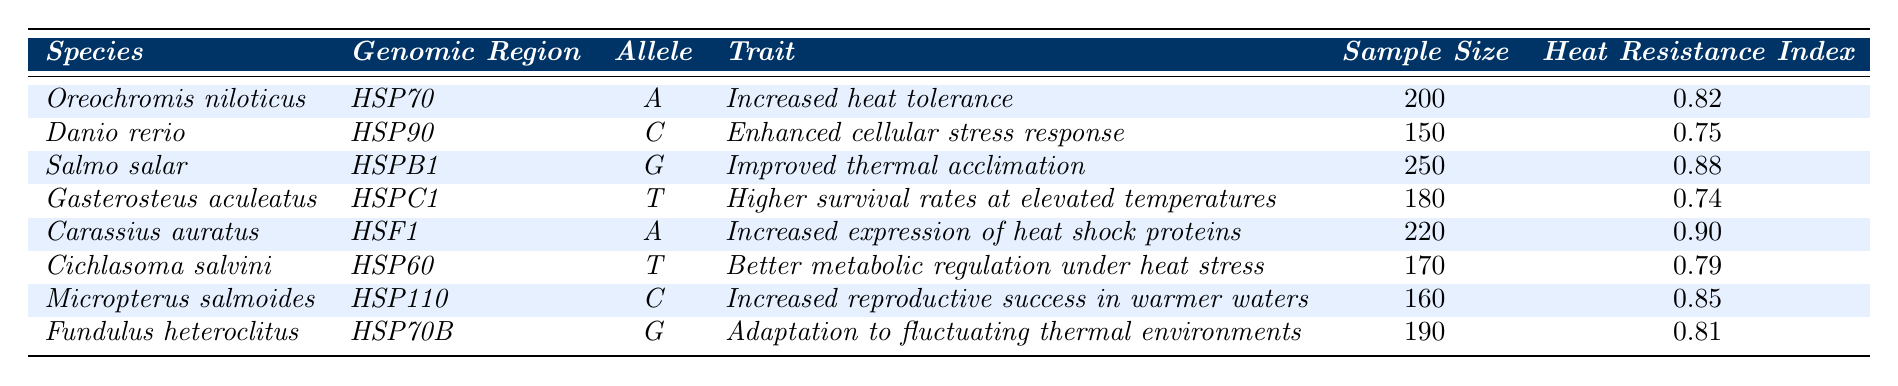What is the heat resistance index for *Salmo salar*? The heat resistance index for *Salmo salar* is directly listed in the table under the corresponding row. It states 0.88 for this species.
Answer: 0.88 Which species has the highest heat resistance index? By comparing the heat resistance index values in the table, *Carassius auratus* has the highest value at 0.90.
Answer: *Carassius auratus* What is the sample size of fish populations for *Gasterosteus aculeatus*? The sample size for *Gasterosteus aculeatus* is explicitly mentioned in the table, which shows a value of 180.
Answer: 180 Is the allele for *Danio rerio* associated with increased heat tolerance? By checking the table, *Danio rerio* has the trait "Enhanced cellular stress response," which is not the same as increased heat tolerance; thus, the answer is no.
Answer: No What is the sum of the heat resistance indices for *Oreochromis niloticus* and *Micropterus salmoides*? The heat resistance index for *Oreochromis niloticus* is 0.82 and for *Micropterus salmoides* it is 0.85. Summing these values gives 0.82 + 0.85 = 1.67.
Answer: 1.67 What proportion of the species listed have a heat resistance index greater than 0.80? From the table, the species with a heat resistance index greater than 0.80 are *Oreochromis niloticus*, *Salmo salar*, *Carassius auratus*, *Micropterus salmoides*, and *Fundulus heteroclitus*. There are 5 out of 8 species, which calculates to 5/8 = 0.625 or 62.5%.
Answer: 62.5% Which genomic region is associated with the allele 'G' in fish? Referring to the table, the allele 'G' is found in the genomic region *HSPB1* for *Salmo salar* and *HSP70B* for *Fundulus heteroclitus*.
Answer: *HSPB1* and *HSP70B* What is the difference in sample size between *Cichlasoma salvini* and *Danio rerio*? The sample size for *Cichlasoma salvini* is 170, and for *Danio rerio*, it is 150. Calculating the difference gives 170 - 150 = 20.
Answer: 20 Which trait is associated with the allele 'A' in *Oreochromis niloticus*? The table shows that the allele 'A' in *Oreochromis niloticus* is associated with the trait "Increased heat tolerance."
Answer: Increased heat tolerance What is the average heat resistance index of the species listed in the table? To find the average, sum all the heat resistance indices (0.82 + 0.75 + 0.88 + 0.74 + 0.90 + 0.79 + 0.85 + 0.81 = 6.83) and divide by the number of species (8). Thus, the average is 6.83 / 8 = 0.85.
Answer: 0.85 